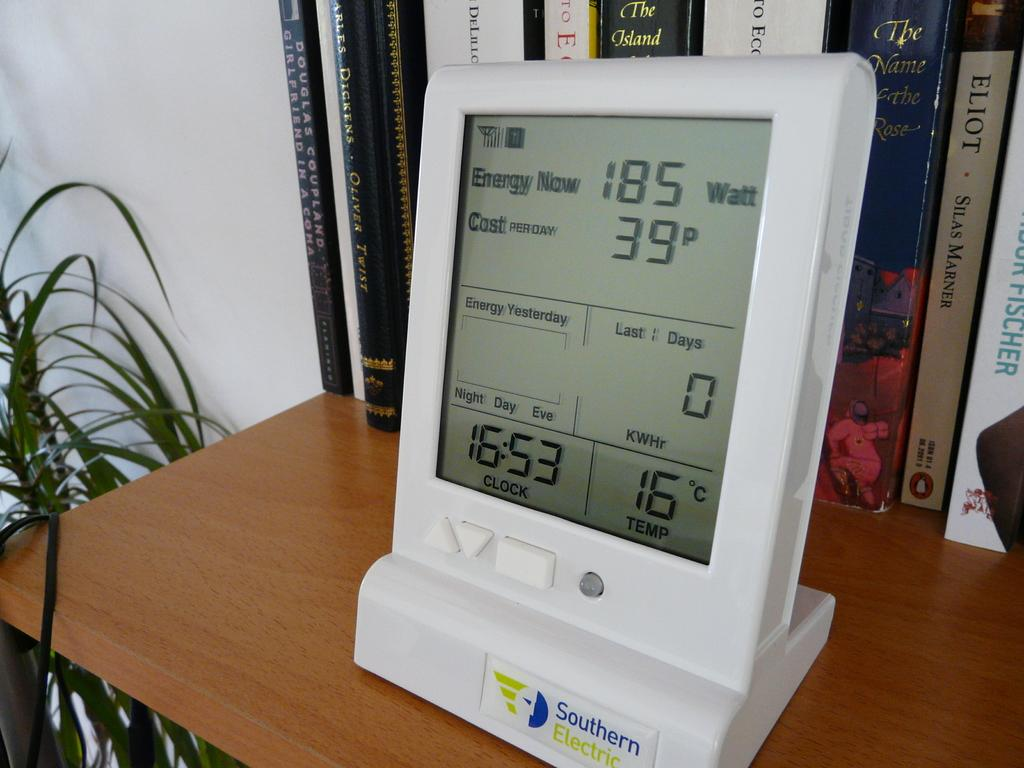<image>
Render a clear and concise summary of the photo. A Southern Electric Energy Meter sits on top of a desk in front of a bookshelf 